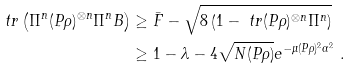<formula> <loc_0><loc_0><loc_500><loc_500>\ t r \left ( \Pi ^ { n } ( P \rho ) ^ { \otimes n } \Pi ^ { n } B \right ) & \geq \bar { F } - \sqrt { 8 \left ( 1 - \ t r ( P \rho ) ^ { \otimes n } \Pi ^ { n } \right ) } \\ & \geq 1 - \lambda - 4 \sqrt { N ( P \rho ) } e ^ { - \mu ( P \rho ) ^ { 2 } \alpha ^ { 2 } } \ .</formula> 